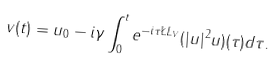<formula> <loc_0><loc_0><loc_500><loc_500>v ( t ) = u _ { 0 } - i \gamma \int _ { 0 } ^ { t } e ^ { - i \tau \L L _ { V } } ( | u | ^ { 2 } u ) ( \tau ) d \tau .</formula> 